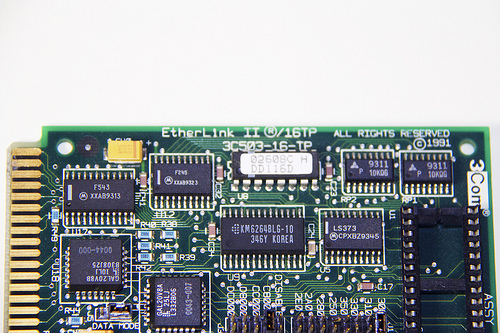<image>
Can you confirm if the chip is next to the connector? No. The chip is not positioned next to the connector. They are located in different areas of the scene. Is there a ic next to the resistor? No. The ic is not positioned next to the resistor. They are located in different areas of the scene. 